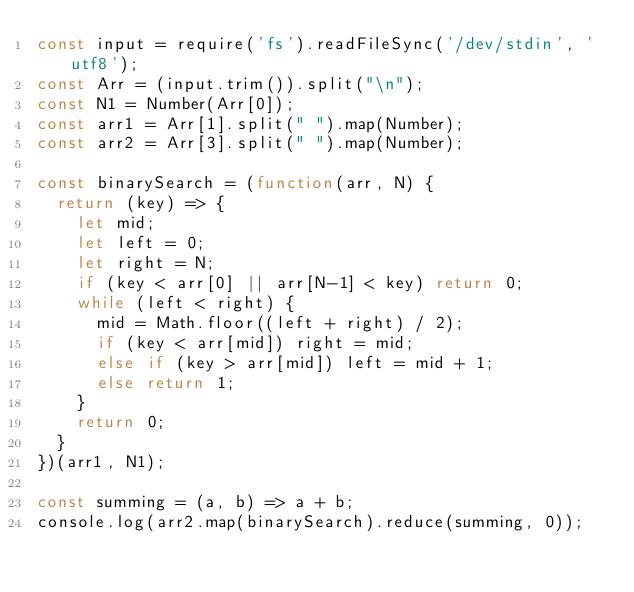<code> <loc_0><loc_0><loc_500><loc_500><_JavaScript_>const input = require('fs').readFileSync('/dev/stdin', 'utf8');
const Arr = (input.trim()).split("\n");
const N1 = Number(Arr[0]);
const arr1 = Arr[1].split(" ").map(Number);
const arr2 = Arr[3].split(" ").map(Number);

const binarySearch = (function(arr, N) {
  return (key) => {   
    let mid;
    let left = 0;
    let right = N;
    if (key < arr[0] || arr[N-1] < key) return 0;
    while (left < right) {
      mid = Math.floor((left + right) / 2);
      if (key < arr[mid]) right = mid;
      else if (key > arr[mid]) left = mid + 1;
      else return 1;
    }
    return 0;
  }
})(arr1, N1);

const summing = (a, b) => a + b;
console.log(arr2.map(binarySearch).reduce(summing, 0));

</code> 